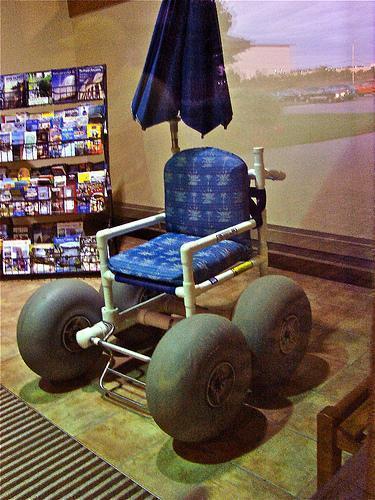What is attached to the chair?
Select the accurate response from the four choices given to answer the question.
Options: Knives, apples, wheels, balloons. Wheels. 